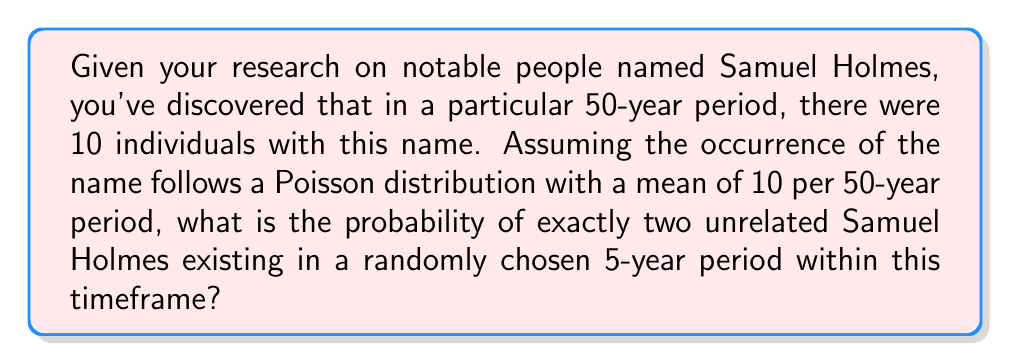What is the answer to this math problem? To solve this problem, we need to follow these steps:

1. Calculate the mean number of Samuel Holmes for a 5-year period:
   The given mean is 10 per 50 years, so for 5 years:
   $\lambda = 10 \times (5/50) = 1$

2. Use the Poisson probability mass function:
   $P(X = k) = \frac{e^{-\lambda} \lambda^k}{k!}$
   where $k$ is the number of occurrences (in this case, 2), and $\lambda$ is the mean (1).

3. Plug in the values:
   $P(X = 2) = \frac{e^{-1} 1^2}{2!}$

4. Simplify:
   $P(X = 2) = \frac{e^{-1}}{2}$

5. Calculate the final value:
   $P(X = 2) \approx 0.1839$

Therefore, the probability of exactly two unrelated Samuel Holmes existing in a randomly chosen 5-year period is approximately 0.1839 or 18.39%.
Answer: $\frac{e^{-1}}{2} \approx 0.1839$ 